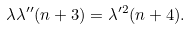Convert formula to latex. <formula><loc_0><loc_0><loc_500><loc_500>\lambda \lambda ^ { \prime \prime } ( n + 3 ) = \lambda ^ { \prime 2 } ( n + 4 ) .</formula> 